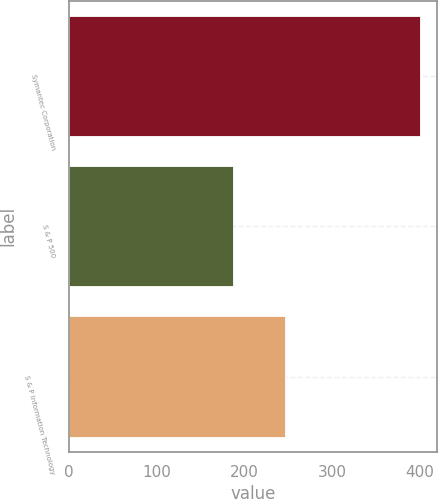Convert chart. <chart><loc_0><loc_0><loc_500><loc_500><bar_chart><fcel>Symantec Corporation<fcel>S & P 500<fcel>S & P Information Technology<nl><fcel>400<fcel>187.08<fcel>246.67<nl></chart> 